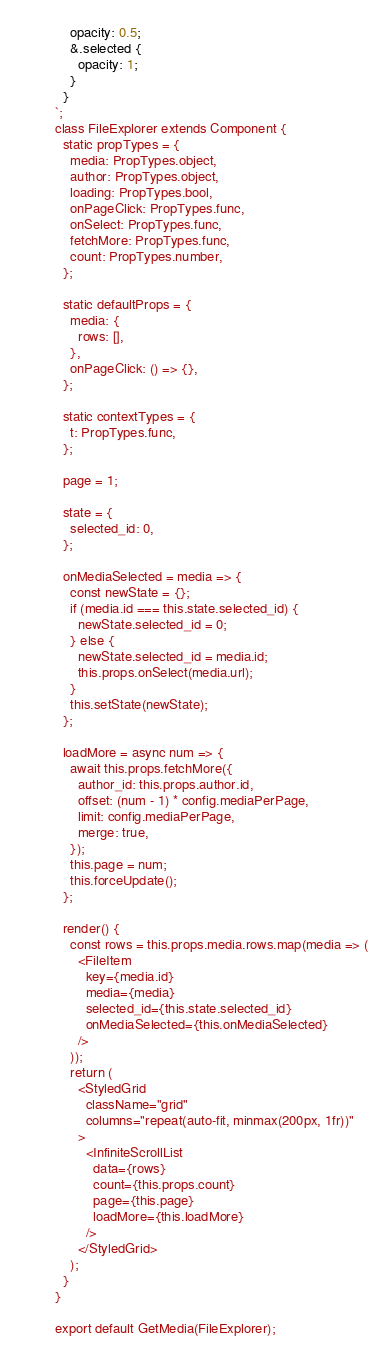Convert code to text. <code><loc_0><loc_0><loc_500><loc_500><_JavaScript_>    opacity: 0.5;
    &.selected {
      opacity: 1;
    }
  }
`;
class FileExplorer extends Component {
  static propTypes = {
    media: PropTypes.object,
    author: PropTypes.object,
    loading: PropTypes.bool,
    onPageClick: PropTypes.func,
    onSelect: PropTypes.func,
    fetchMore: PropTypes.func,
    count: PropTypes.number,
  };

  static defaultProps = {
    media: {
      rows: [],
    },
    onPageClick: () => {},
  };

  static contextTypes = {
    t: PropTypes.func,
  };

  page = 1;

  state = {
    selected_id: 0,
  };

  onMediaSelected = media => {
    const newState = {};
    if (media.id === this.state.selected_id) {
      newState.selected_id = 0;
    } else {
      newState.selected_id = media.id;
      this.props.onSelect(media.url);
    }
    this.setState(newState);
  };

  loadMore = async num => {
    await this.props.fetchMore({
      author_id: this.props.author.id,
      offset: (num - 1) * config.mediaPerPage,
      limit: config.mediaPerPage,
      merge: true,
    });
    this.page = num;
    this.forceUpdate();
  };

  render() {
    const rows = this.props.media.rows.map(media => (
      <FileItem
        key={media.id}
        media={media}
        selected_id={this.state.selected_id}
        onMediaSelected={this.onMediaSelected}
      />
    ));
    return (
      <StyledGrid
        className="grid"
        columns="repeat(auto-fit, minmax(200px, 1fr))"
      >
        <InfiniteScrollList
          data={rows}
          count={this.props.count}
          page={this.page}
          loadMore={this.loadMore}
        />
      </StyledGrid>
    );
  }
}

export default GetMedia(FileExplorer);
</code> 